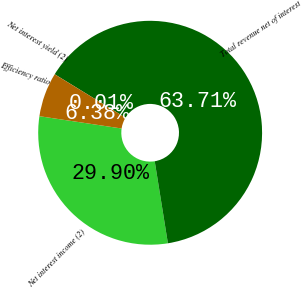<chart> <loc_0><loc_0><loc_500><loc_500><pie_chart><fcel>Net interest income (2)<fcel>Total revenue net of interest<fcel>Net interest yield (2)<fcel>Efficiency ratio<nl><fcel>29.9%<fcel>63.71%<fcel>0.01%<fcel>6.38%<nl></chart> 